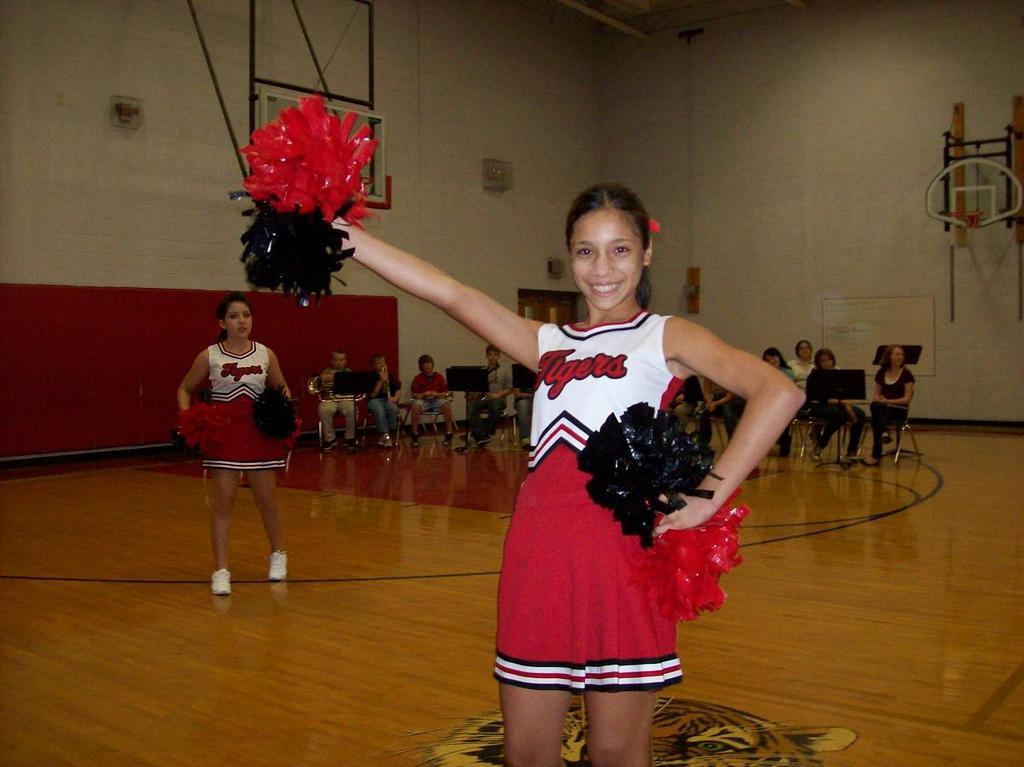<image>
Relay a brief, clear account of the picture shown. A Cheerleader with a red and white "Tigers" outfit 